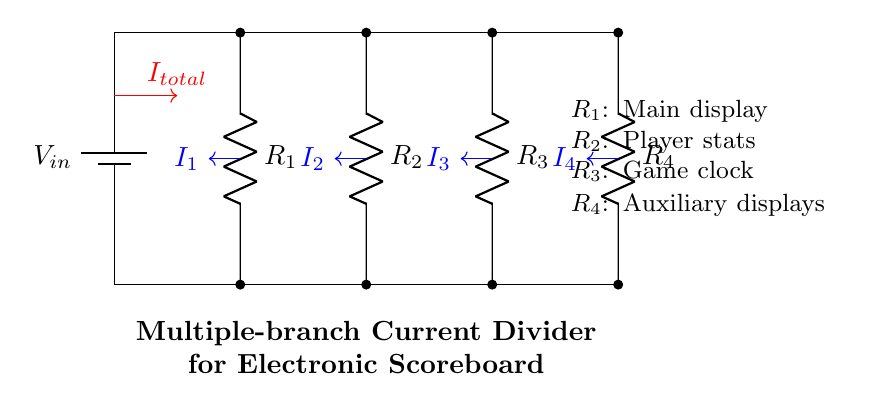What is the input voltage of the circuit? The input voltage is the voltage provided by the battery, labeled as V_in in the diagram. It directly connects to the top of the resistors, thus it is the source voltage for this circuit.
Answer: V_in How many resistors are in the circuit? There are four resistors represented in the diagram. Each of the resistors is connected in parallel to the input voltage, indicating multiple paths for current flow.
Answer: Four What does R_1 represent in the circuit? R_1 is labeled as the main display in the circuit. This indicates its function related to the electronic scoreboard, providing the primary visual output.
Answer: Main display What is the total current entering the current divider? The total current entering the current divider is represented by I_total, which flows into the parallel arrangement of resistors. This total current is then divided among the branches.
Answer: I_total Which resistor is dedicated to the game clock? R_3 is dedicated to the game clock, as indicated in the diagram. Each resistor is labeled to show its specific application in the electronic scoreboard.
Answer: R_3 How is the current divided in this circuit? The current is divided inversely proportional to the resistance values of each branch. Lower resistance in a branch leads to a higher current through that branch, following the current divider rule.
Answer: Inversely proportional What feature of the circuit signifies it is a current divider? The presence of multiple resistors connected in parallel to the same voltage source signifies that this configuration allows for current division. Each resistor receives a portion of the total current according to its resistance value.
Answer: Multiple resistors in parallel 